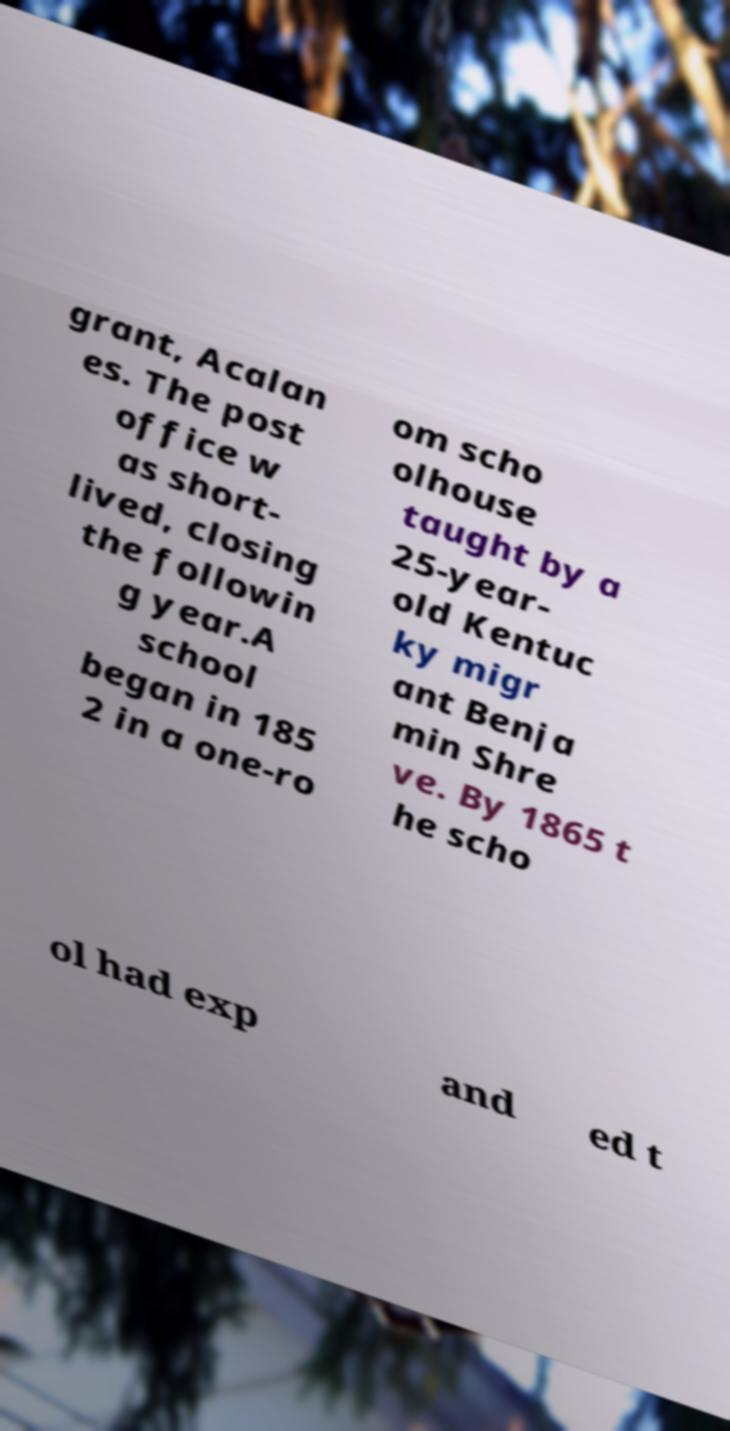Can you read and provide the text displayed in the image?This photo seems to have some interesting text. Can you extract and type it out for me? grant, Acalan es. The post office w as short- lived, closing the followin g year.A school began in 185 2 in a one-ro om scho olhouse taught by a 25-year- old Kentuc ky migr ant Benja min Shre ve. By 1865 t he scho ol had exp and ed t 